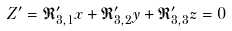Convert formula to latex. <formula><loc_0><loc_0><loc_500><loc_500>Z ^ { \prime } = \mathfrak { R } ^ { \prime } _ { 3 , 1 } x + \mathfrak { R } ^ { \prime } _ { 3 , 2 } y + \mathfrak { R } ^ { \prime } _ { 3 , 3 } z = 0</formula> 